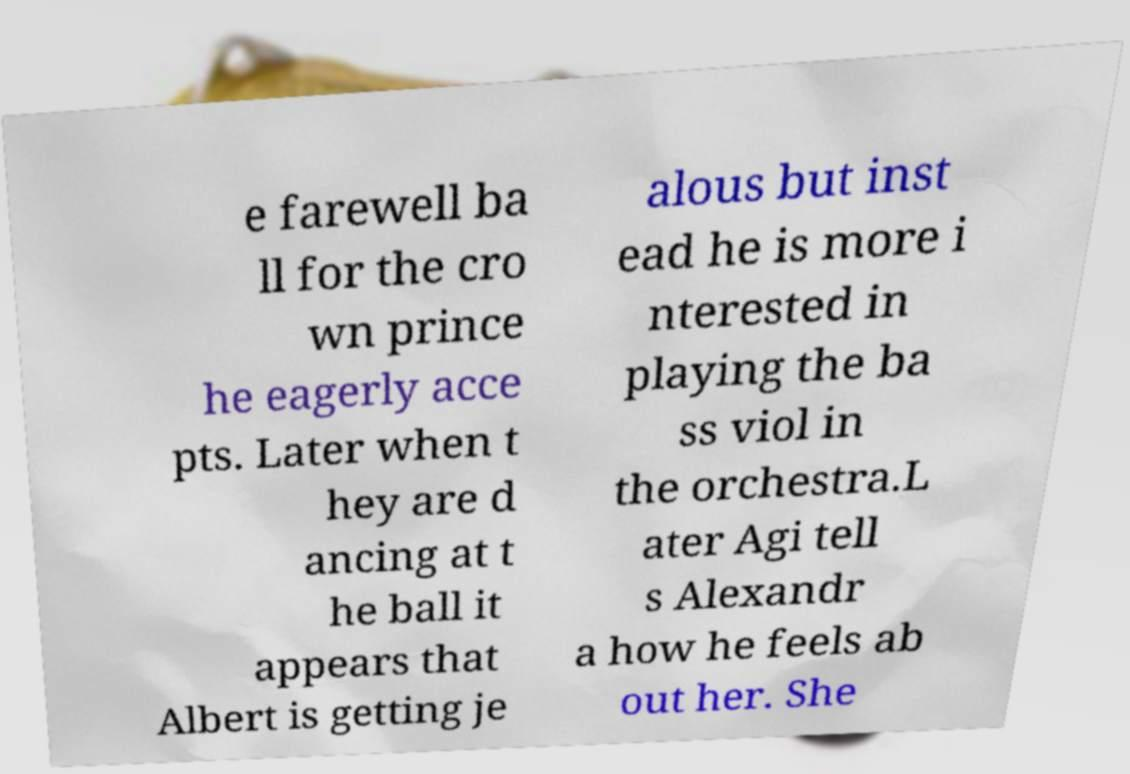Can you accurately transcribe the text from the provided image for me? e farewell ba ll for the cro wn prince he eagerly acce pts. Later when t hey are d ancing at t he ball it appears that Albert is getting je alous but inst ead he is more i nterested in playing the ba ss viol in the orchestra.L ater Agi tell s Alexandr a how he feels ab out her. She 